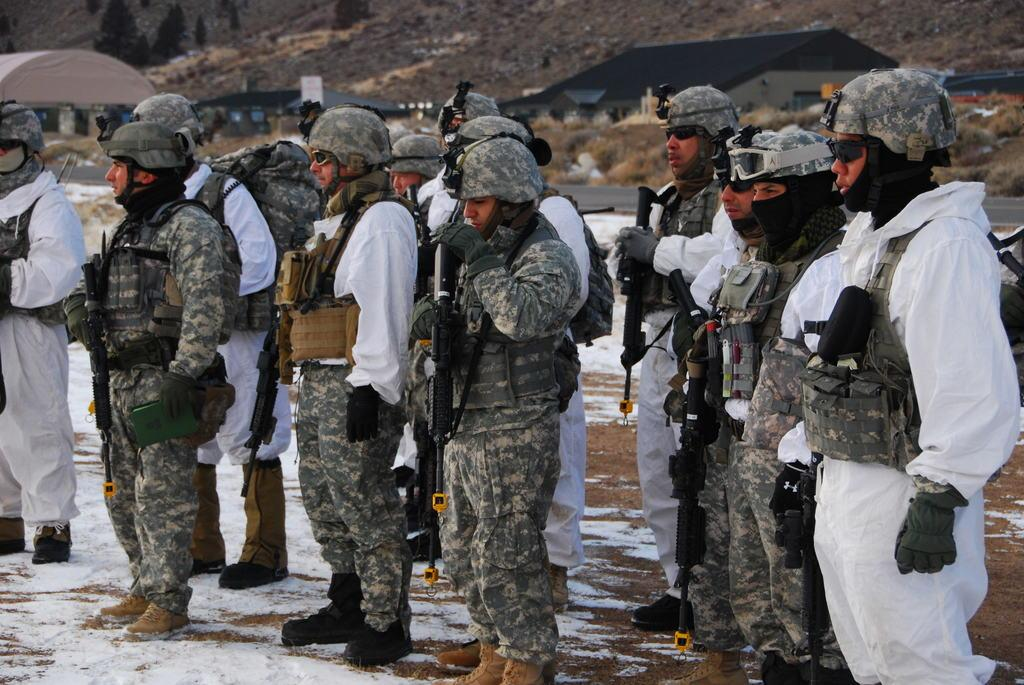How many people are in the image? There is a group of people in the image, but the exact number is not specified. What are the people doing in the image? The people are standing and holding rifles. What can be seen in the background of the image? There is snow, trees, plants, and houses in the background of the image. What type of silk is draped over the top of the trees in the image? There is no silk present in the image; it features a group of people standing with rifles, surrounded by snow, trees, plants, and houses in the background. 